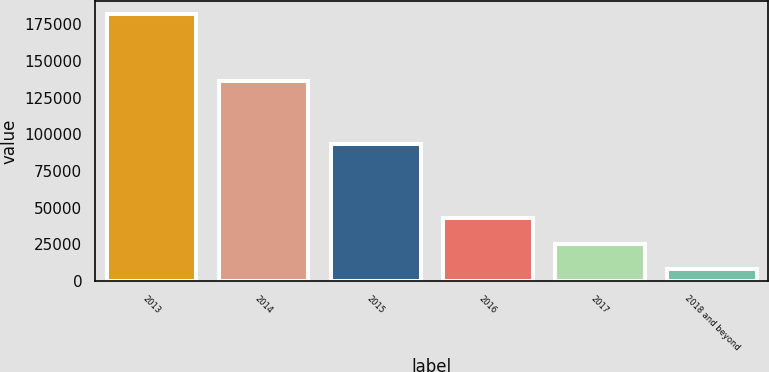<chart> <loc_0><loc_0><loc_500><loc_500><bar_chart><fcel>2013<fcel>2014<fcel>2015<fcel>2016<fcel>2017<fcel>2018 and beyond<nl><fcel>181800<fcel>136419<fcel>93625<fcel>42680<fcel>25290<fcel>7900<nl></chart> 